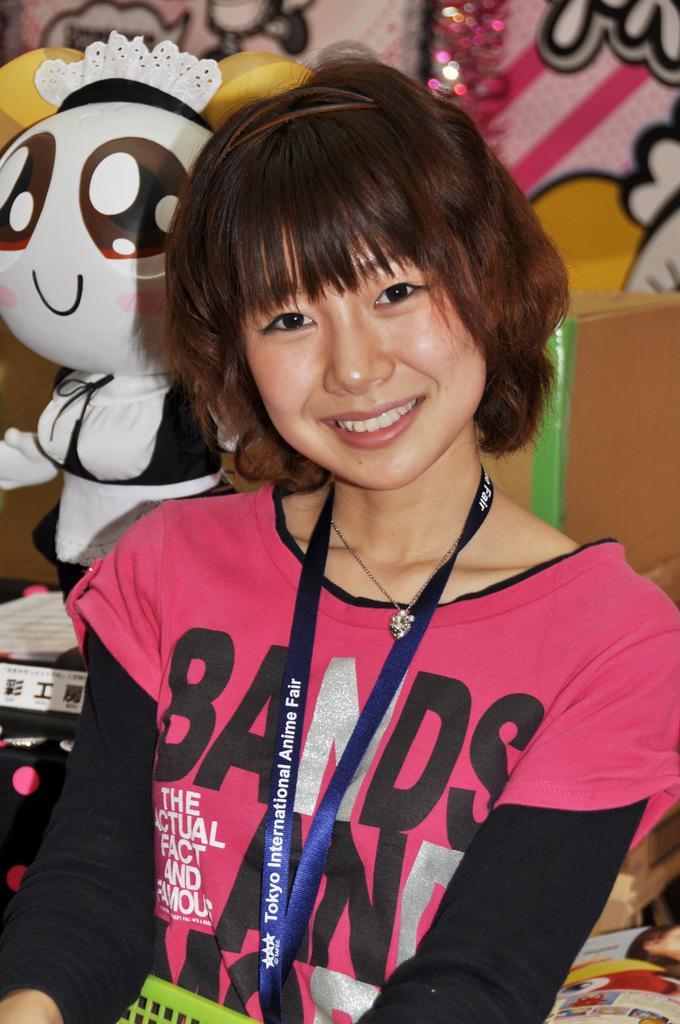Could you give a brief overview of what you see in this image? In this picture I can see a girl in the middle, she is smiling, on the left side there is a doll. In the background there are paintings on the wall. 